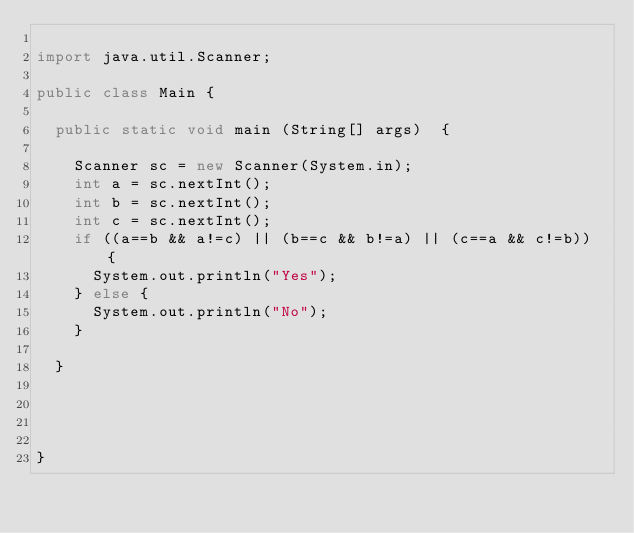Convert code to text. <code><loc_0><loc_0><loc_500><loc_500><_Java_>
import java.util.Scanner;

public class Main {

	public static void main (String[] args)  {

		Scanner sc = new Scanner(System.in);
		int a = sc.nextInt();
		int b = sc.nextInt();
		int c = sc.nextInt();
		if ((a==b && a!=c) || (b==c && b!=a) || (c==a && c!=b)) {
			System.out.println("Yes");
		} else {
			System.out.println("No");
		}
 
	}

	
	

}
</code> 